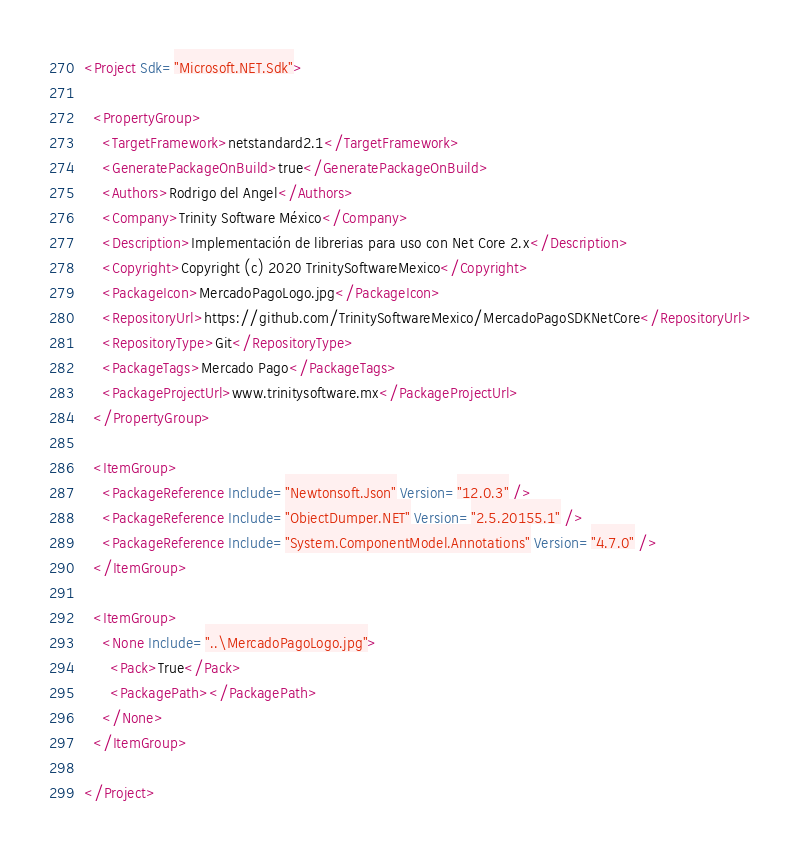Convert code to text. <code><loc_0><loc_0><loc_500><loc_500><_XML_><Project Sdk="Microsoft.NET.Sdk">

  <PropertyGroup>
    <TargetFramework>netstandard2.1</TargetFramework>
    <GeneratePackageOnBuild>true</GeneratePackageOnBuild>
    <Authors>Rodrigo del Angel</Authors>
    <Company>Trinity Software México</Company>
    <Description>Implementación de librerias para uso con Net Core 2.x</Description>
    <Copyright>Copyright (c) 2020 TrinitySoftwareMexico</Copyright>
    <PackageIcon>MercadoPagoLogo.jpg</PackageIcon>
    <RepositoryUrl>https://github.com/TrinitySoftwareMexico/MercadoPagoSDKNetCore</RepositoryUrl>
    <RepositoryType>Git</RepositoryType>
    <PackageTags>Mercado Pago</PackageTags>
    <PackageProjectUrl>www.trinitysoftware.mx</PackageProjectUrl>
  </PropertyGroup>

  <ItemGroup>
    <PackageReference Include="Newtonsoft.Json" Version="12.0.3" />
    <PackageReference Include="ObjectDumper.NET" Version="2.5.20155.1" />
    <PackageReference Include="System.ComponentModel.Annotations" Version="4.7.0" />
  </ItemGroup>

  <ItemGroup>
    <None Include="..\MercadoPagoLogo.jpg">
      <Pack>True</Pack>
      <PackagePath></PackagePath>
    </None>
  </ItemGroup>

</Project>
</code> 